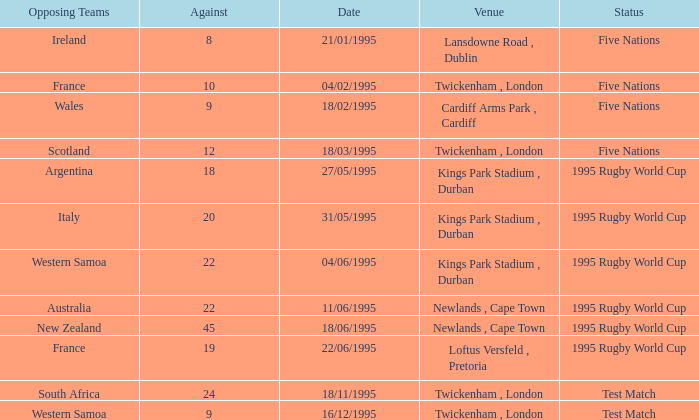When was the status test match with an opposing team of south africa? 18/11/1995. 